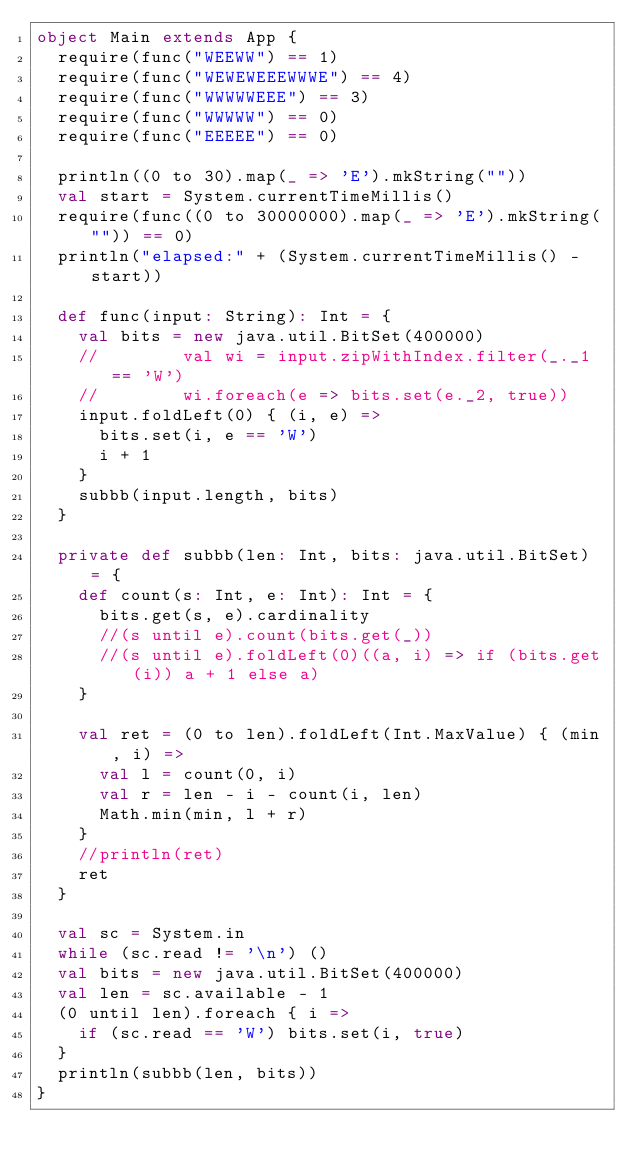<code> <loc_0><loc_0><loc_500><loc_500><_Scala_>object Main extends App {
	require(func("WEEWW") == 1)
	require(func("WEWEWEEEWWWE") == 4)
	require(func("WWWWWEEE") == 3)
	require(func("WWWWW") == 0)
	require(func("EEEEE") == 0)

	println((0 to 30).map(_ => 'E').mkString(""))
	val start = System.currentTimeMillis()
	require(func((0 to 30000000).map(_ => 'E').mkString("")) == 0)
	println("elapsed:" + (System.currentTimeMillis() - start))

	def func(input: String): Int = {
		val bits = new java.util.BitSet(400000)
		//				val wi = input.zipWithIndex.filter(_._1 == 'W')
		//				wi.foreach(e => bits.set(e._2, true))
		input.foldLeft(0) { (i, e) =>
			bits.set(i, e == 'W')
			i + 1
		}
		subbb(input.length, bits)
	}

	private def subbb(len: Int, bits: java.util.BitSet) = {
		def count(s: Int, e: Int): Int = {
			bits.get(s, e).cardinality
			//(s until e).count(bits.get(_))
			//(s until e).foldLeft(0)((a, i) => if (bits.get(i)) a + 1 else a)
		}

		val ret = (0 to len).foldLeft(Int.MaxValue) { (min, i) =>
			val l = count(0, i)
			val r = len - i - count(i, len)
			Math.min(min, l + r)
		}
		//println(ret)
		ret
	}

	val sc = System.in
	while (sc.read != '\n') ()
	val bits = new java.util.BitSet(400000)
	val len = sc.available - 1
	(0 until len).foreach { i =>
		if (sc.read == 'W') bits.set(i, true)
	}
	println(subbb(len, bits))
}
</code> 